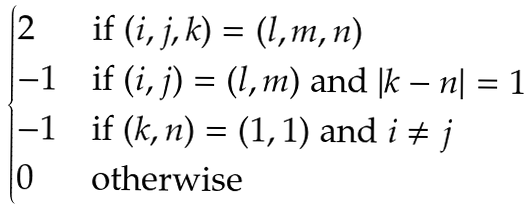<formula> <loc_0><loc_0><loc_500><loc_500>\begin{cases} 2 & \text {if } ( i , j , k ) = ( l , m , n ) \\ - 1 & \text {if } ( i , j ) = ( l , m ) \text { and } | k - n | = 1 \\ - 1 & \text {if } ( k , n ) = ( 1 , 1 ) \text { and } i \neq j \\ 0 & \text {otherwise} \end{cases}</formula> 